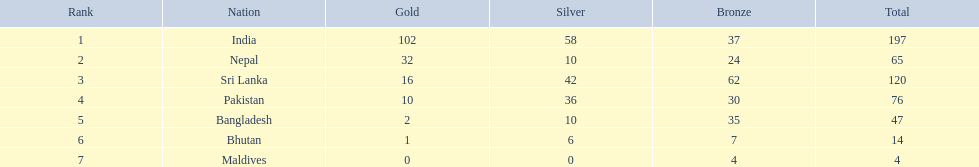How many extra gold medals has nepal secured over pakistan? 22. 